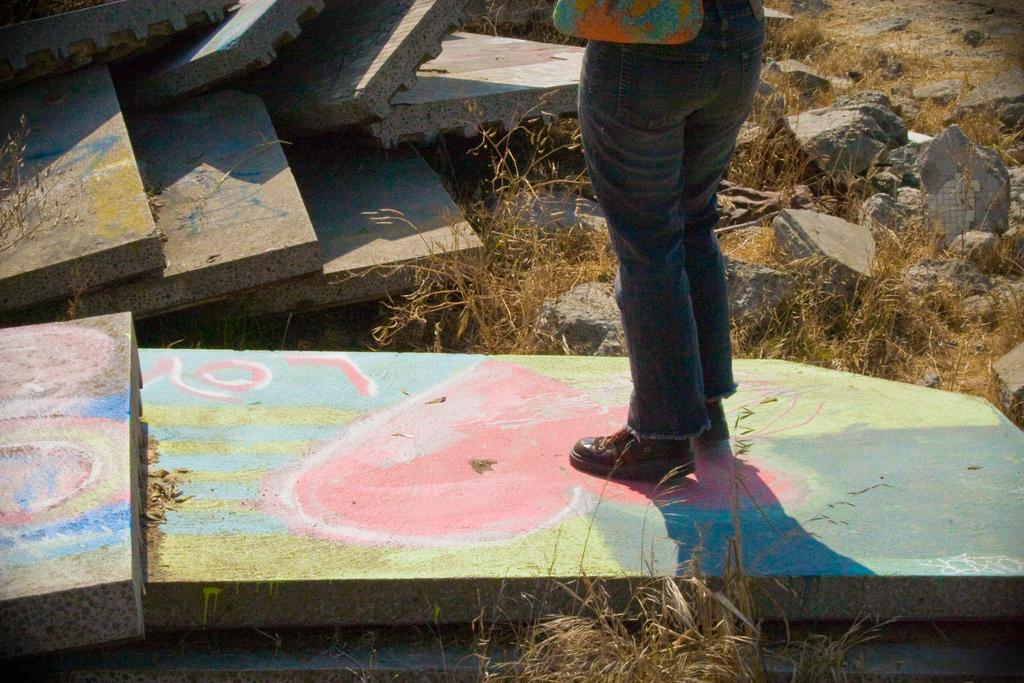What is the person in the image standing on? The person is standing on stones. What type of vegetation can be seen in the image? Dried grass is visible in the image. What type of cannon is present in the image? There is no cannon present in the image. How many bubbles can be seen floating in the image? There are no bubbles present in the image. 